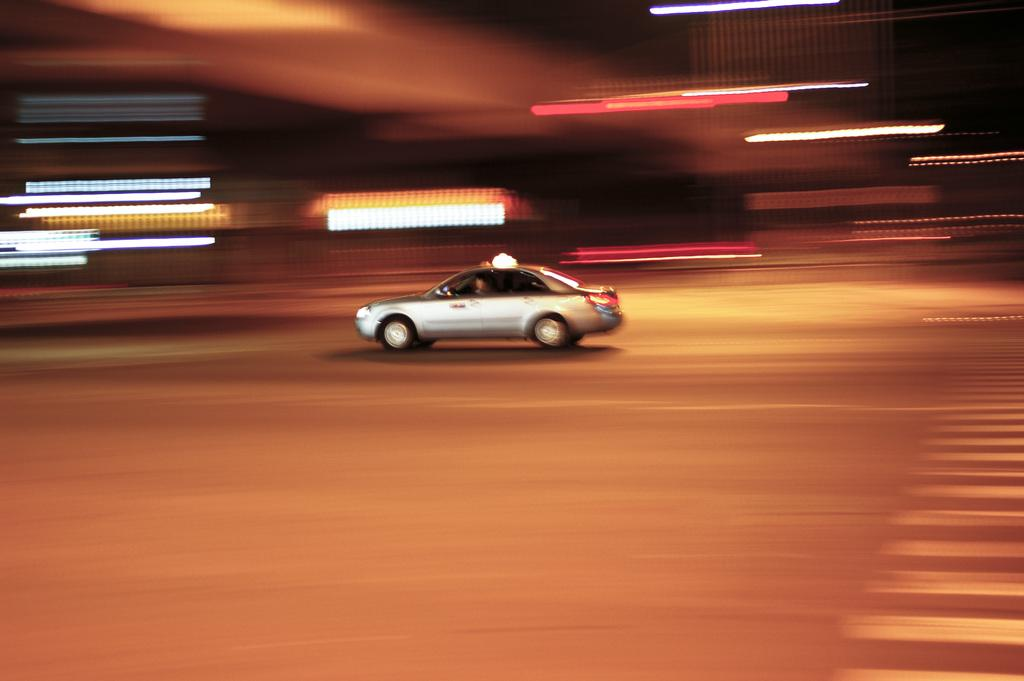What is the main subject in the image? There is a car in the center of the image. What religious symbols can be seen on the car in the image? There are no religious symbols visible on the car in the image. What force is being applied to the car in the image? There is no indication of any force being applied to the car in the image; it appears to be stationary. Can you hear a whistle in the image? There is no sound or indication of a whistle in the image. 